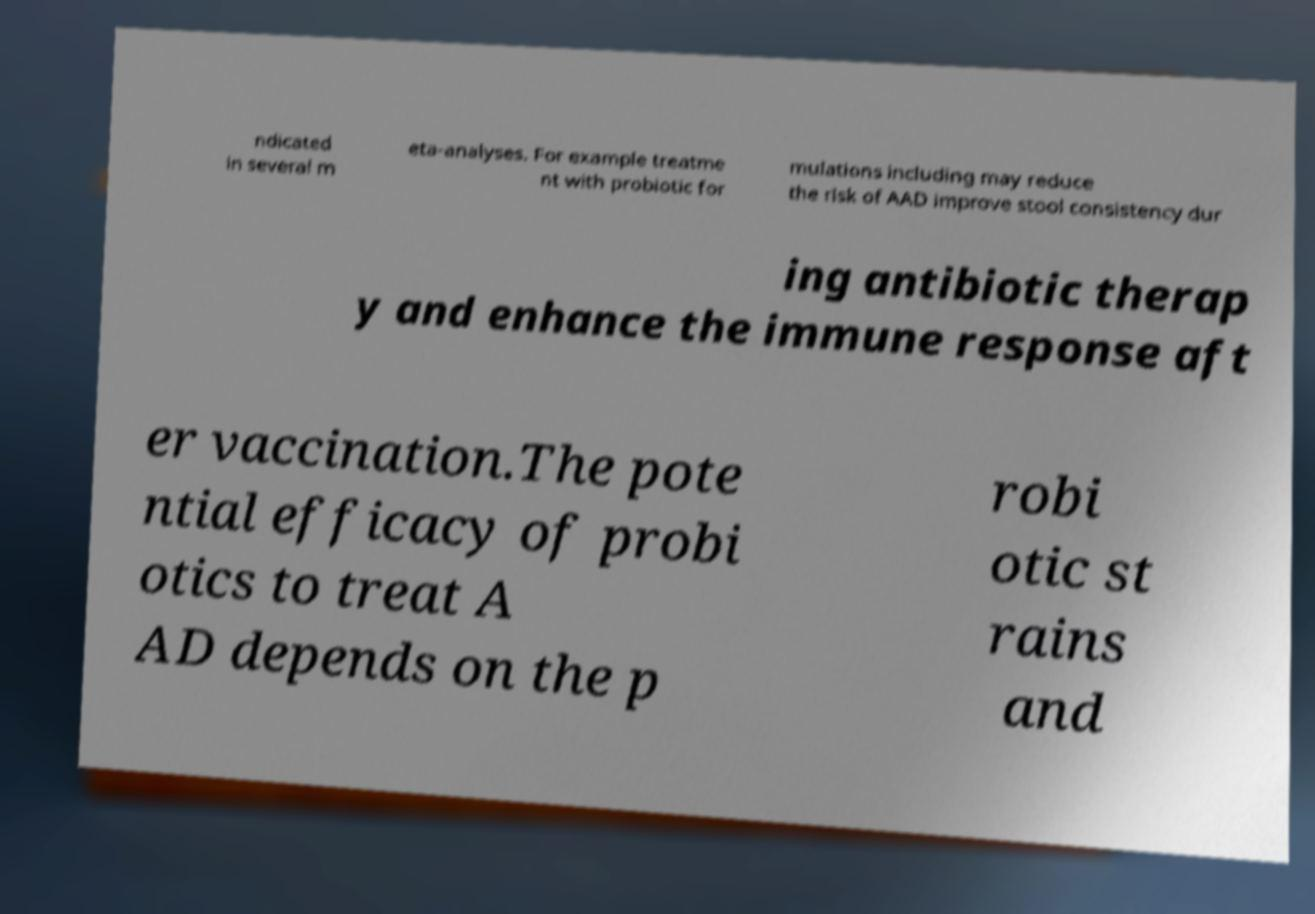Can you read and provide the text displayed in the image?This photo seems to have some interesting text. Can you extract and type it out for me? ndicated in several m eta-analyses. For example treatme nt with probiotic for mulations including may reduce the risk of AAD improve stool consistency dur ing antibiotic therap y and enhance the immune response aft er vaccination.The pote ntial efficacy of probi otics to treat A AD depends on the p robi otic st rains and 